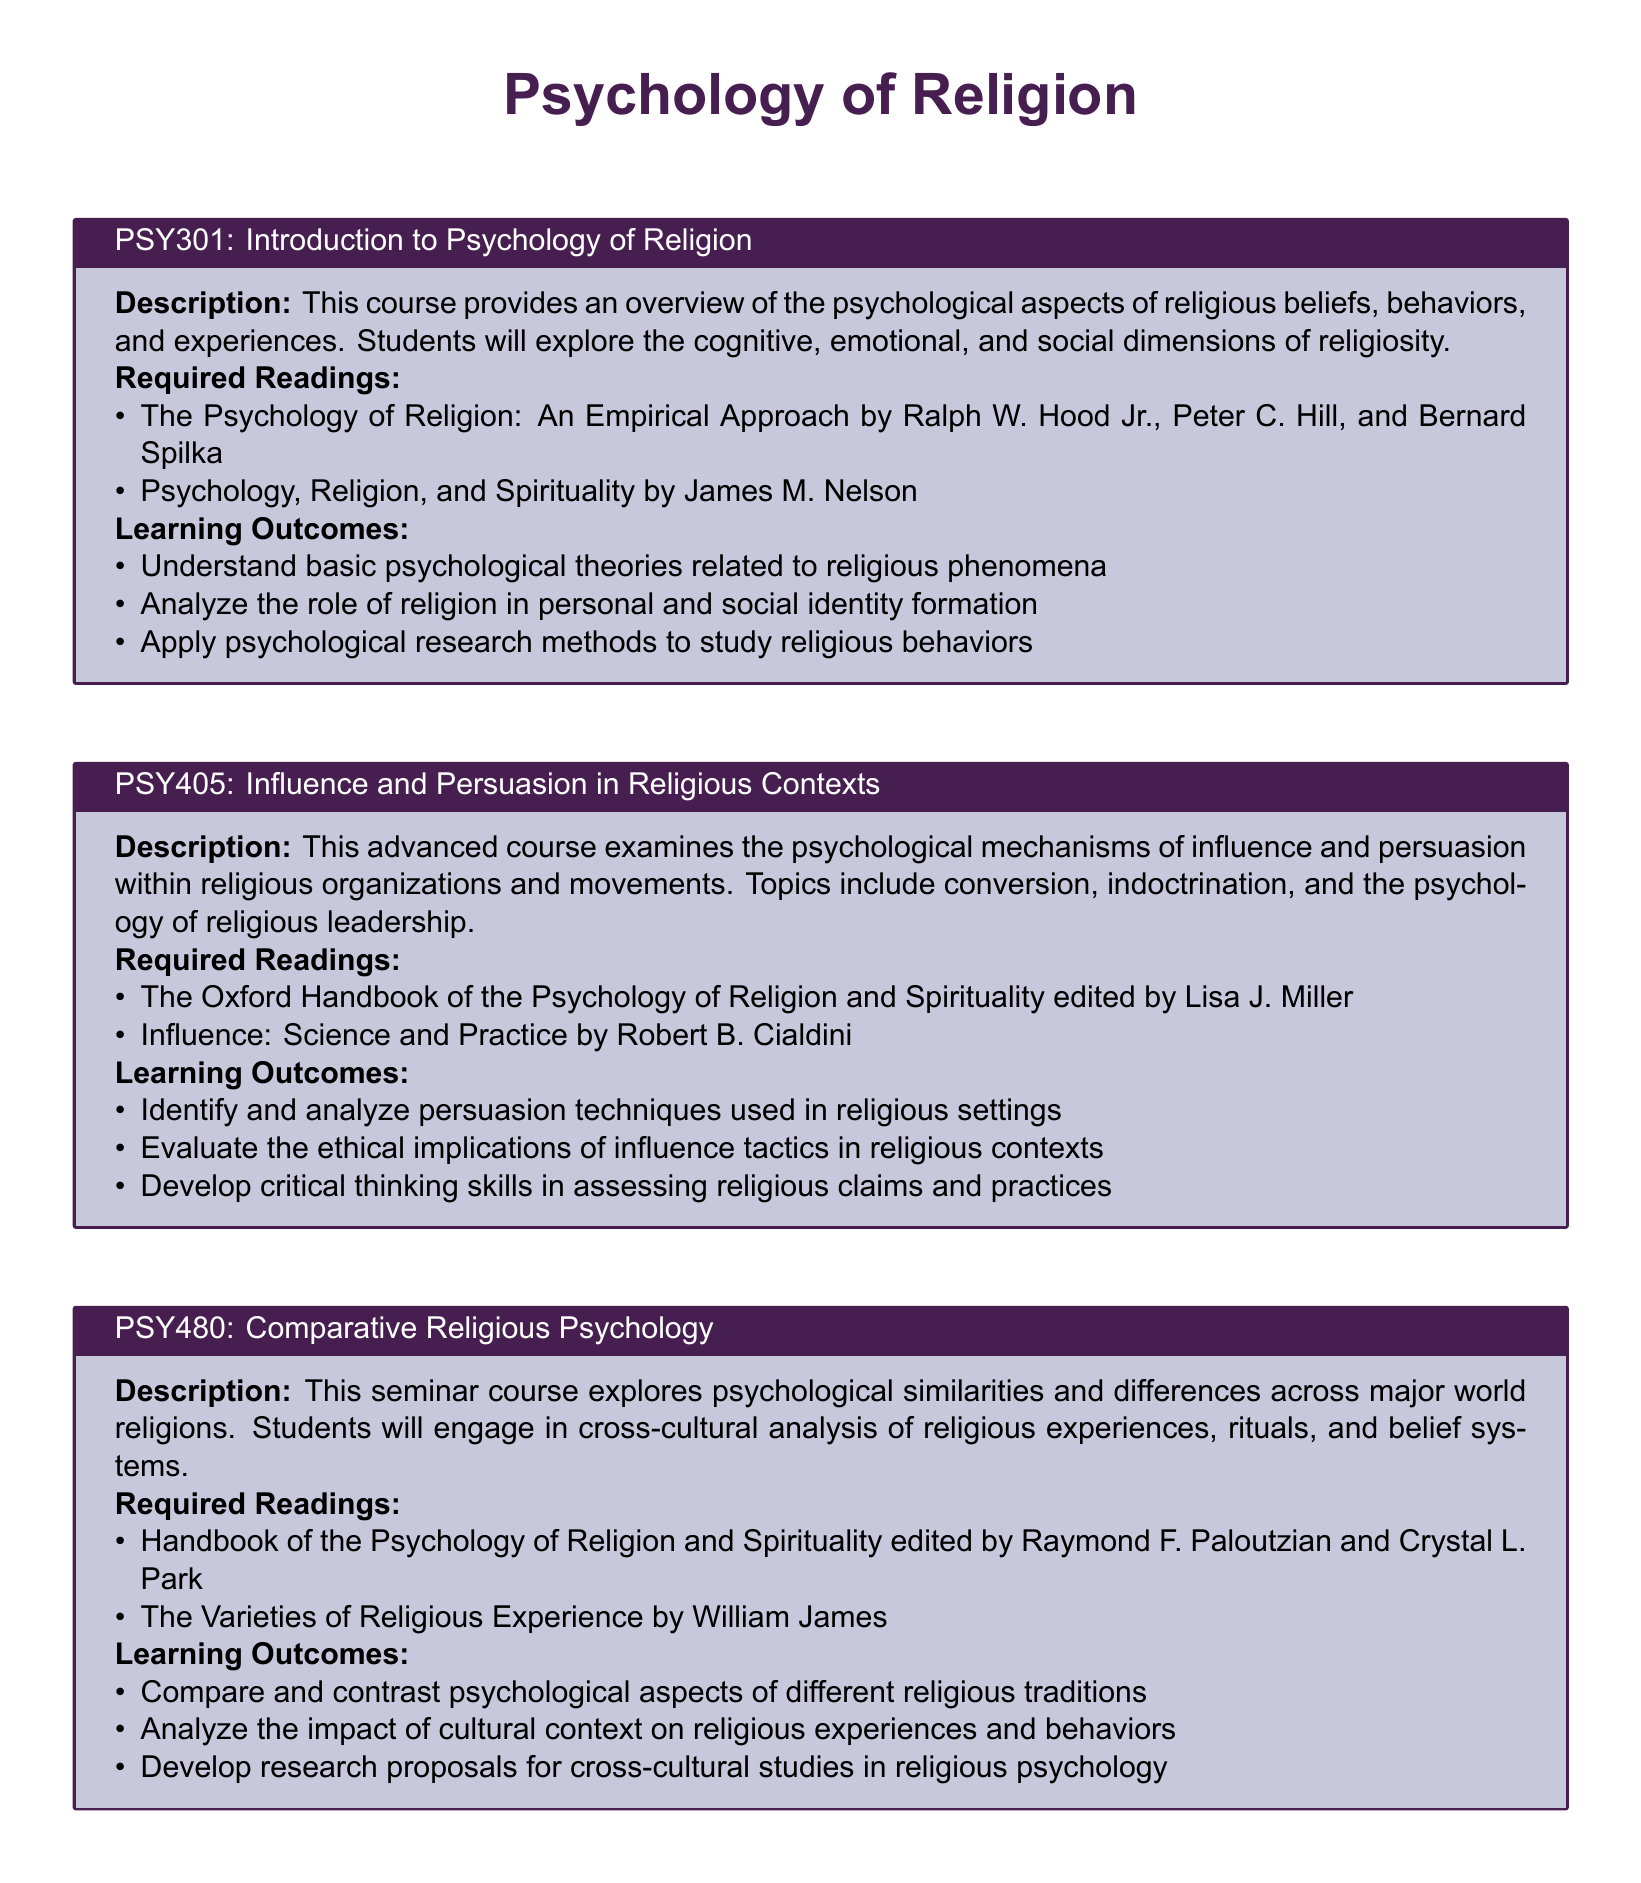What is the title of the course PSY301? The title of the course PSY301 is "Introduction to Psychology of Religion."
Answer: Introduction to Psychology of Religion Who is the author of "The Psychology of Religion: An Empirical Approach"? The author of "The Psychology of Religion: An Empirical Approach" is Ralph W. Hood Jr., Peter C. Hill, and Bernard Spilka.
Answer: Ralph W. Hood Jr., Peter C. Hill, and Bernard Spilka What are the learning outcomes of the course PSY480? The learning outcomes include comparing psychological aspects of different religious traditions, analyzing cultural context impacts, and developing research proposals.
Answer: Compare and contrast psychological aspects of different religious traditions, Analyze the impact of cultural context on religious experiences and behaviors, Develop research proposals for cross-cultural studies in religious psychology How many courses are listed in the catalog? The catalog lists three courses in total.
Answer: 3 What is the focus of PSY405? PSY405 focuses on the psychological mechanisms of influence and persuasion within religious organizations and movements.
Answer: Psychological mechanisms of influence and persuasion Which book is required reading for PSY480? The required reading for PSY480 is "Handbook of the Psychology of Religion and Spirituality."
Answer: Handbook of the Psychology of Religion and Spirituality What type of course is PSY480? PSY480 is described as a seminar course.
Answer: Seminar course What year is the document styled for? The document is styled for 11pt font size on A4 paper.
Answer: 11pt, A4 paper What is one of the learning outcomes for PSY405? One of the learning outcomes for PSY405 is to evaluate the ethical implications of influence tactics in religious contexts.
Answer: Evaluate the ethical implications of influence tactics in religious contexts 